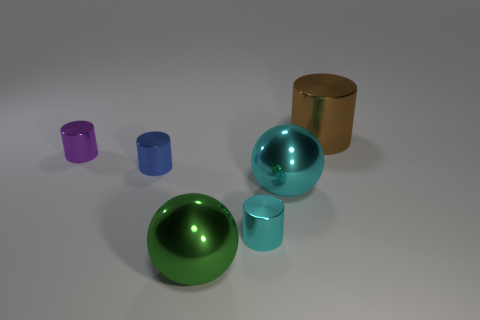Subtract all small cylinders. How many cylinders are left? 1 Add 1 cyan cylinders. How many objects exist? 7 Subtract 4 cylinders. How many cylinders are left? 0 Subtract all blue cylinders. How many cylinders are left? 3 Add 5 big cyan shiny objects. How many big cyan shiny objects exist? 6 Subtract 0 gray cylinders. How many objects are left? 6 Subtract all cylinders. How many objects are left? 2 Subtract all yellow spheres. Subtract all red cylinders. How many spheres are left? 2 Subtract all yellow blocks. How many purple cylinders are left? 1 Subtract all small cyan cylinders. Subtract all big metallic balls. How many objects are left? 3 